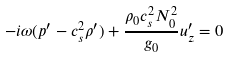Convert formula to latex. <formula><loc_0><loc_0><loc_500><loc_500>- i \omega ( p ^ { \prime } - c _ { s } ^ { 2 } \rho ^ { \prime } ) + \frac { \rho _ { 0 } c _ { s } ^ { 2 } N _ { 0 } ^ { 2 } } { g _ { 0 } } u ^ { \prime } _ { z } = 0</formula> 